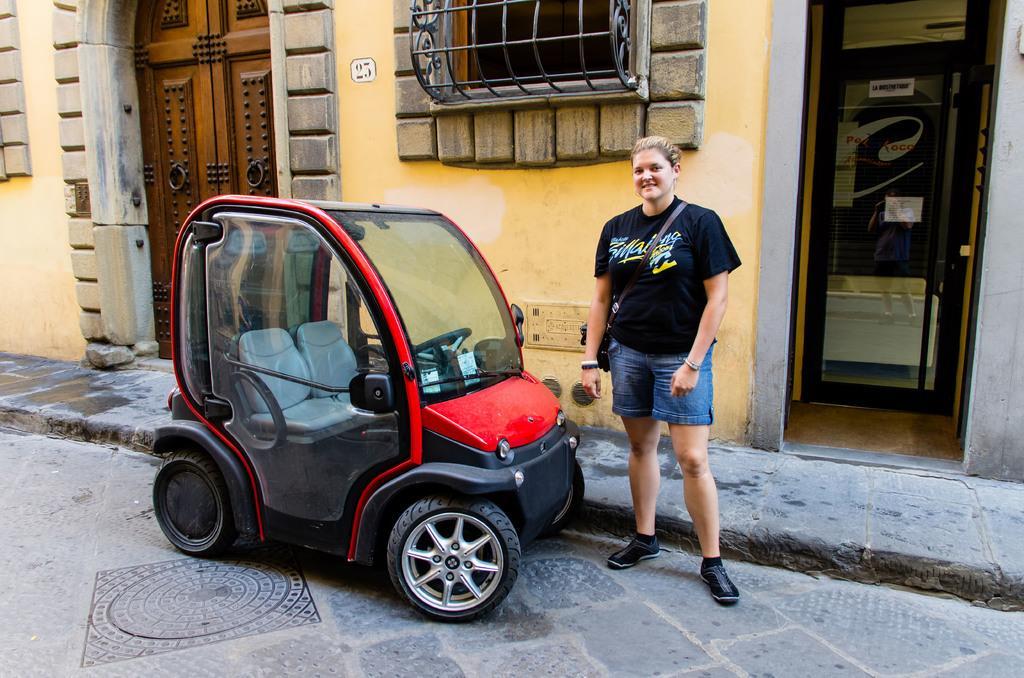Describe this image in one or two sentences. In this picture we can see the women wearing black t- shirt and blue shorts, standing in the front and giving a pose in the camera. Beside there is a small electric car. Behind we can see the yellow wall with wooden door and windows. 